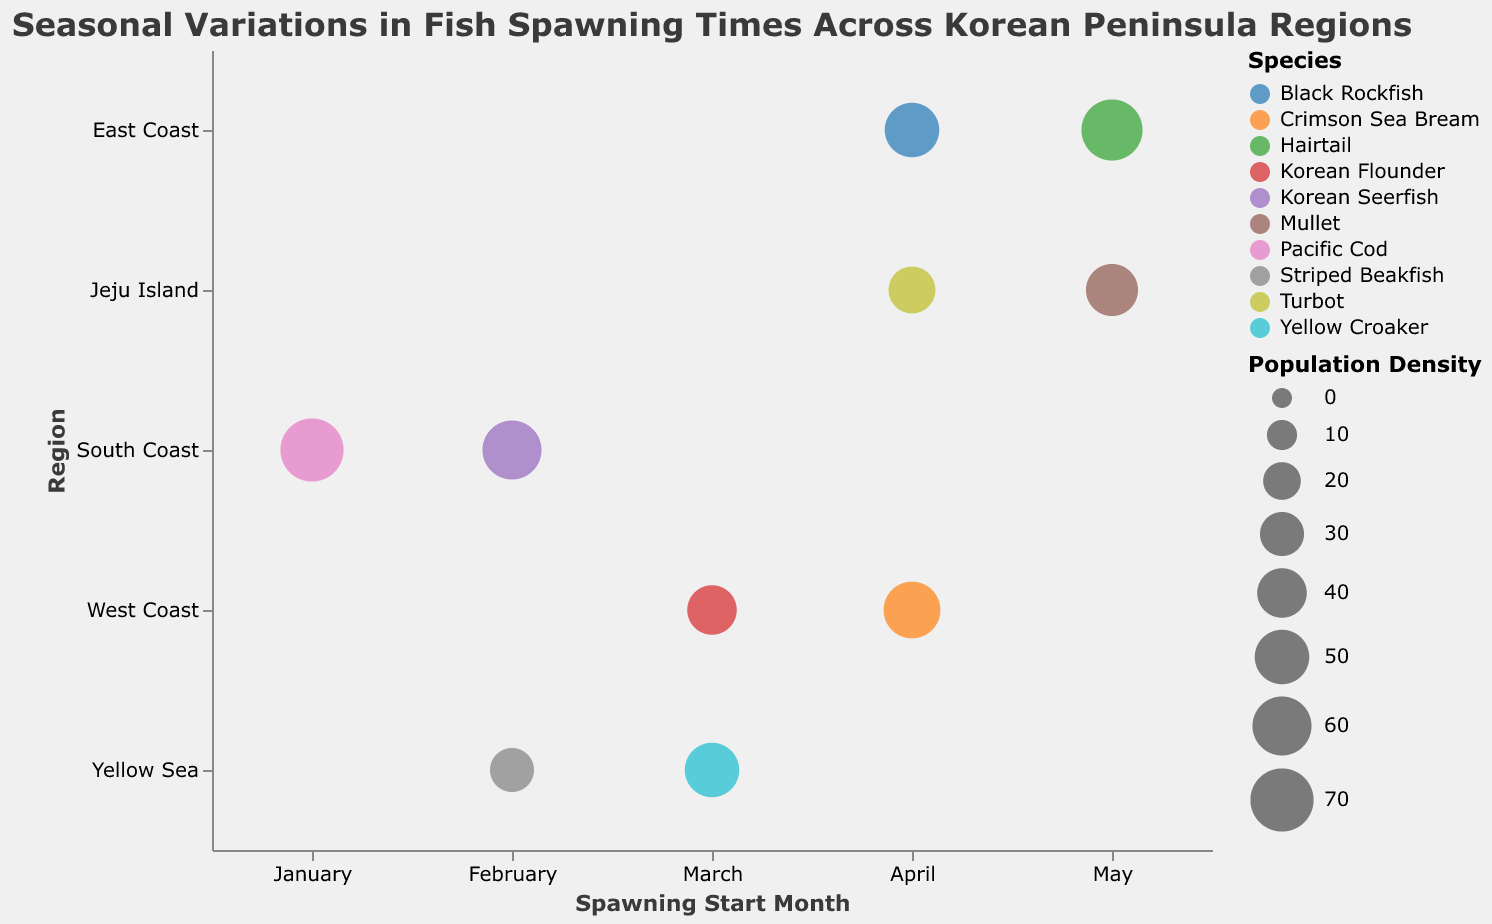What is the title of the chart? The title of the chart is found at the top and is typically larger and more prominent than other text. It provides a summary of what the chart is about.
Answer: Seasonal Variations in Fish Spawning Times Across Korean Peninsula Regions Which region has the species with the highest population density? Identify the largest bubble in terms of size, which indicates the highest population density, and note the corresponding region.
Answer: South Coast During which months does the spawning period of Pacific Cod occur? Look at the position of the bubble representing Pacific Cod on the x-axis, which shows the spawning start month, and the tooltip information will provide the end month.
Answer: January to March How many species spawn on the East Coast? Look at the y-axis for the "East Coast" region and count the number of distinct bubbles associated with this region.
Answer: 2 Which species has the smallest population density on Jeju Island? Locate the bubbles under the "Jeju Island" region on the y-axis and compare their sizes. The smallest bubble indicates the smallest population density.
Answer: Turbot Which species starts spawning in April on the West Coast? Look at the x-axis for the month "April" and identify the bubbles that intersect with the "West Coast" region.
Answer: Crimson Sea Bream Which species start spawning in February? Look at the x-axis for "February" and identify all the bubbles in this column.
Answer: Korean Seerfish, Striped Beakfish Compare the spawning periods of Korean Flounder and Yellow Croaker. Which one has an earlier spawning start month? Identify the bubbles for Korean Flounder and Yellow Croaker and compare their x-axis positions for the spawning start month.
Answer: Korean Flounder What is the average population density of the species on the West Coast? Find the population densities of all species in the West Coast region: Korean Flounder (40), Crimson Sea Bream (55). Calculate the average: (40 + 55) / 2 = 47.5.
Answer: 47.5 